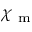<formula> <loc_0><loc_0><loc_500><loc_500>\chi _ { m }</formula> 